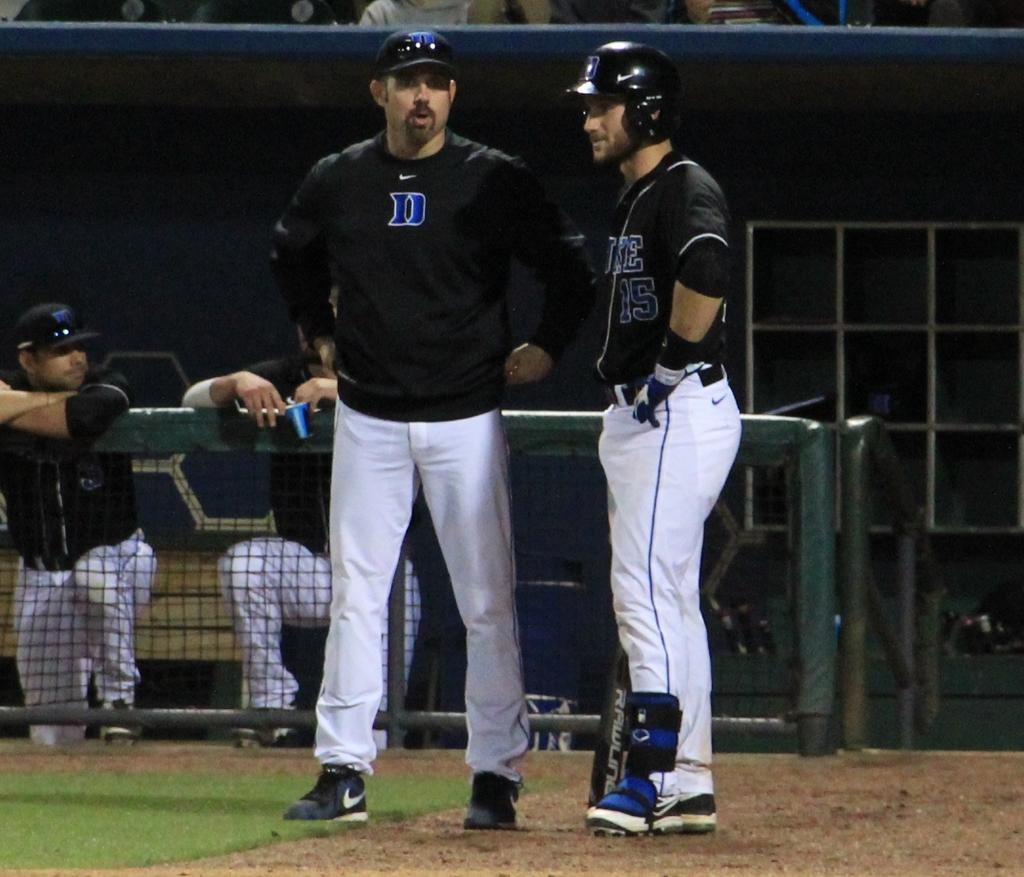Provide a one-sentence caption for the provided image. Baseball player wearing a black jersey with the number 15 talking to another player. 